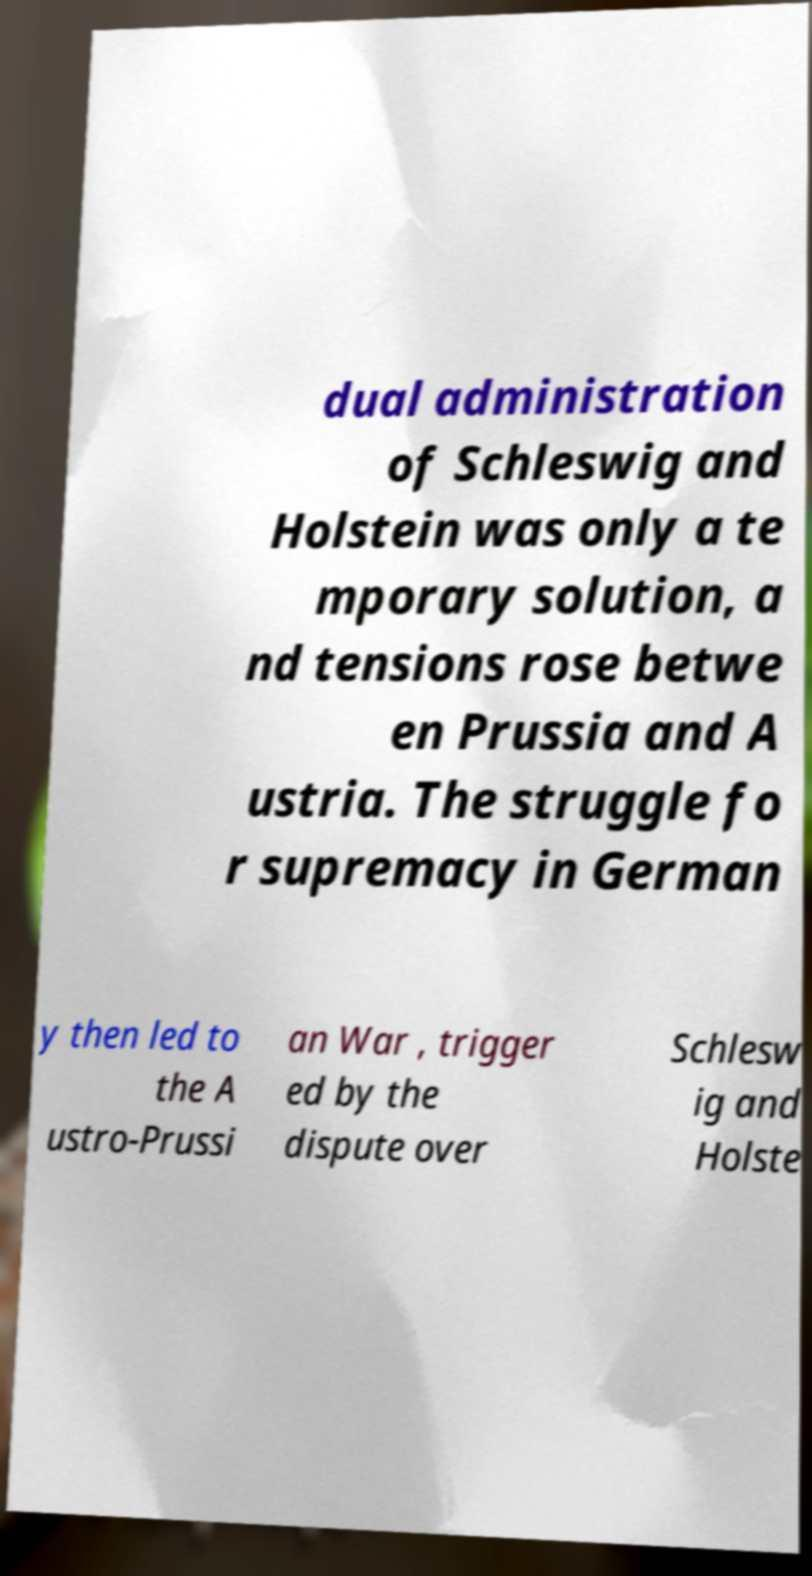Could you assist in decoding the text presented in this image and type it out clearly? dual administration of Schleswig and Holstein was only a te mporary solution, a nd tensions rose betwe en Prussia and A ustria. The struggle fo r supremacy in German y then led to the A ustro-Prussi an War , trigger ed by the dispute over Schlesw ig and Holste 